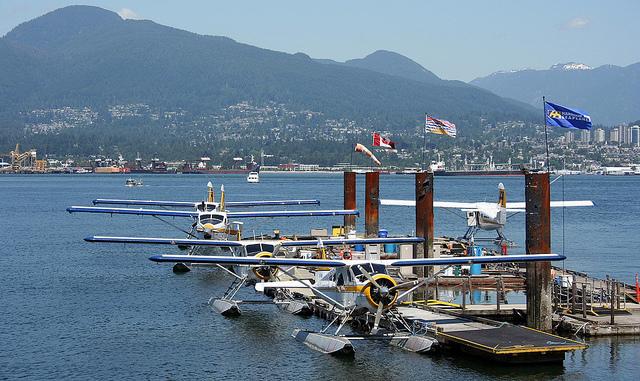How many airplanes are in the water?
Be succinct. 5. How many aircraft wings are there?
Give a very brief answer. 10. Are these planes on a runway?
Quick response, please. No. 